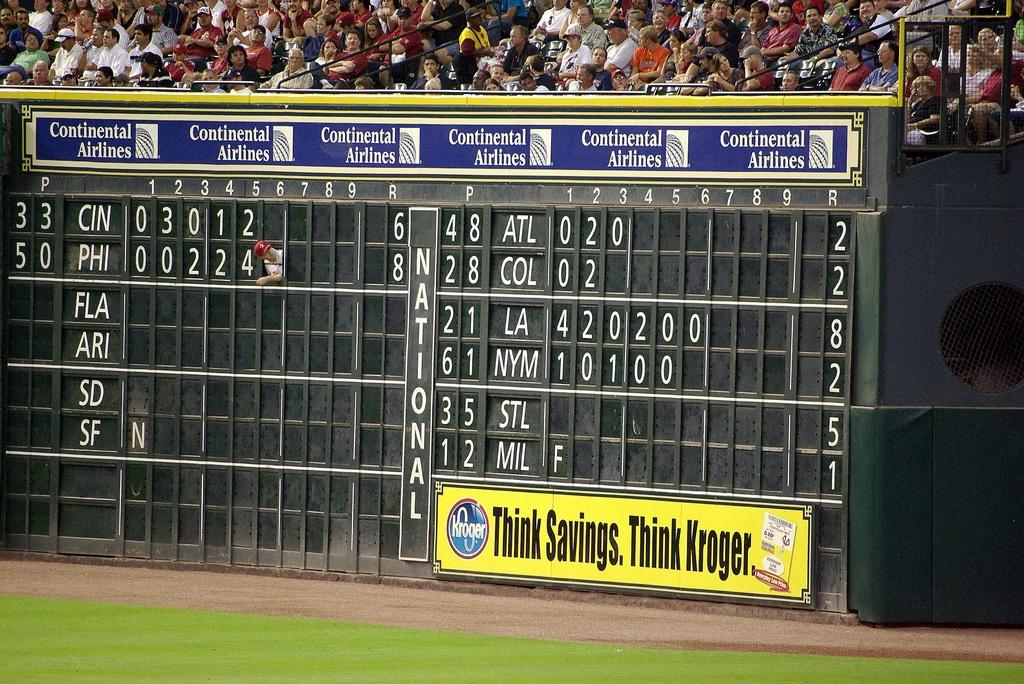<image>
Present a compact description of the photo's key features. An outdoor scoreboard with Continental Airlines on it. 